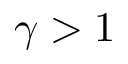Convert formula to latex. <formula><loc_0><loc_0><loc_500><loc_500>\gamma > 1</formula> 